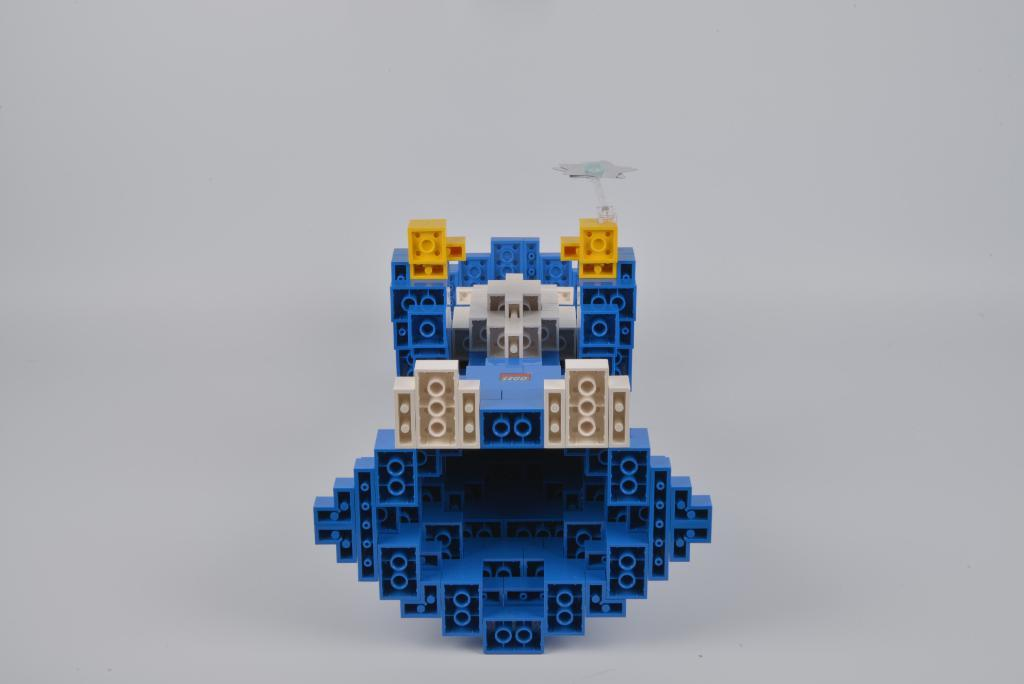What is the main subject in the center of the image? There is a toy in the center of the image. What color is the background of the image? The background of the image is white. How many cacti are present in the image? There are no cacti present in the image; it only features a toy and a white background. 